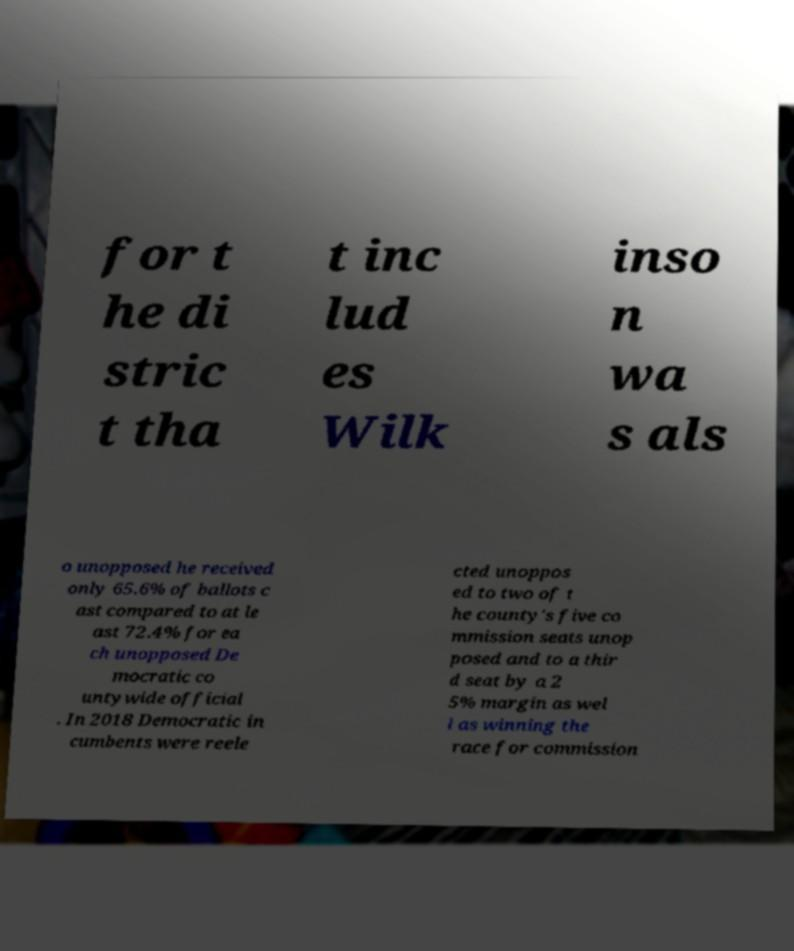I need the written content from this picture converted into text. Can you do that? for t he di stric t tha t inc lud es Wilk inso n wa s als o unopposed he received only 65.6% of ballots c ast compared to at le ast 72.4% for ea ch unopposed De mocratic co untywide official . In 2018 Democratic in cumbents were reele cted unoppos ed to two of t he county's five co mmission seats unop posed and to a thir d seat by a 2 5% margin as wel l as winning the race for commission 